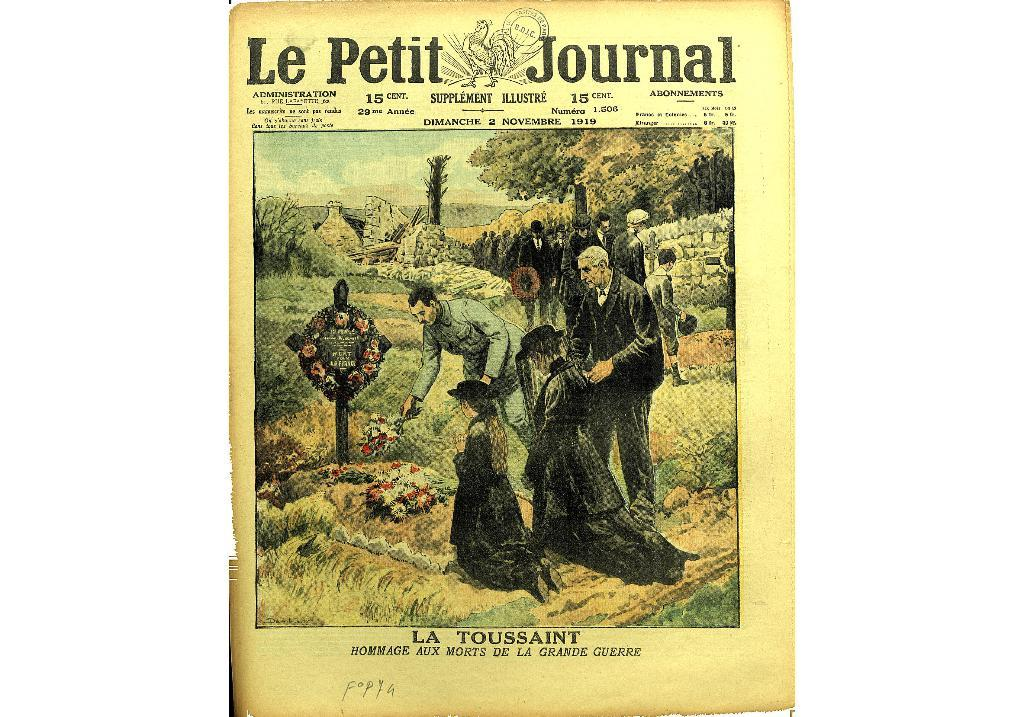<image>
Render a clear and concise summary of the photo. The front page of Le Petit Journal dimanche 2 novembre 1919. 